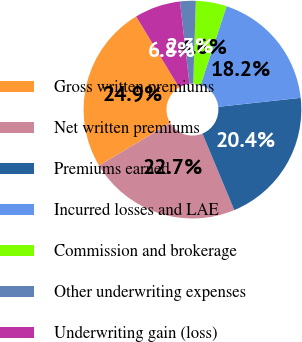<chart> <loc_0><loc_0><loc_500><loc_500><pie_chart><fcel>Gross written premiums<fcel>Net written premiums<fcel>Premiums earned<fcel>Incurred losses and LAE<fcel>Commission and brokerage<fcel>Other underwriting expenses<fcel>Underwriting gain (loss)<nl><fcel>24.94%<fcel>22.69%<fcel>20.44%<fcel>18.2%<fcel>4.58%<fcel>2.33%<fcel>6.82%<nl></chart> 